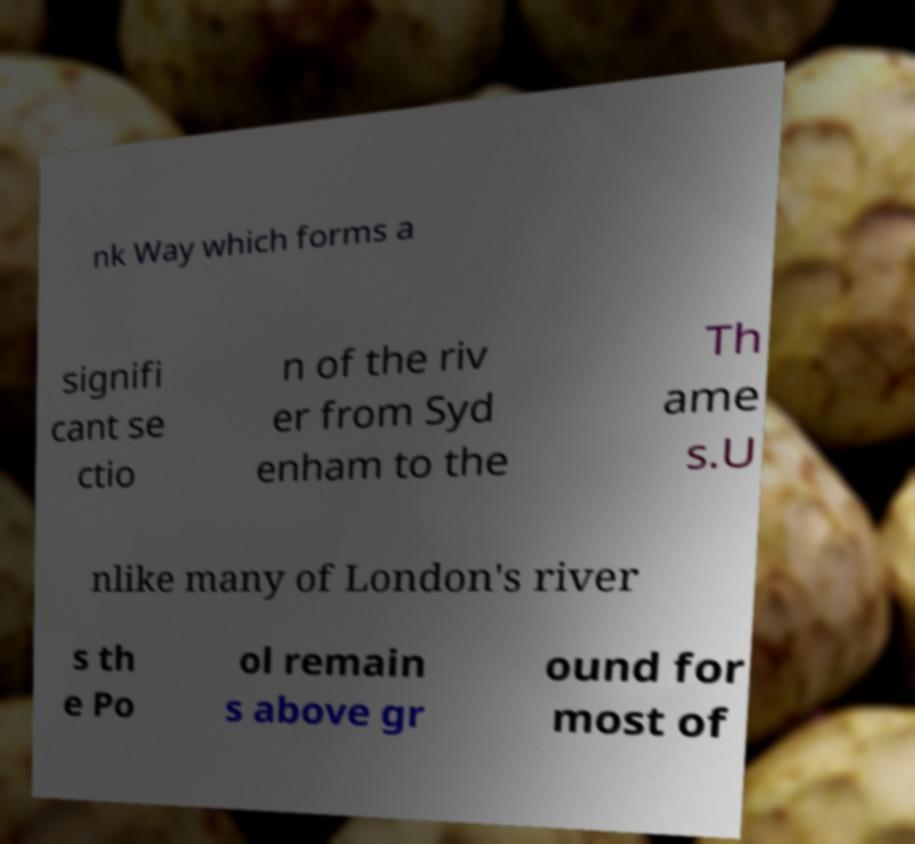Can you read and provide the text displayed in the image?This photo seems to have some interesting text. Can you extract and type it out for me? nk Way which forms a signifi cant se ctio n of the riv er from Syd enham to the Th ame s.U nlike many of London's river s th e Po ol remain s above gr ound for most of 